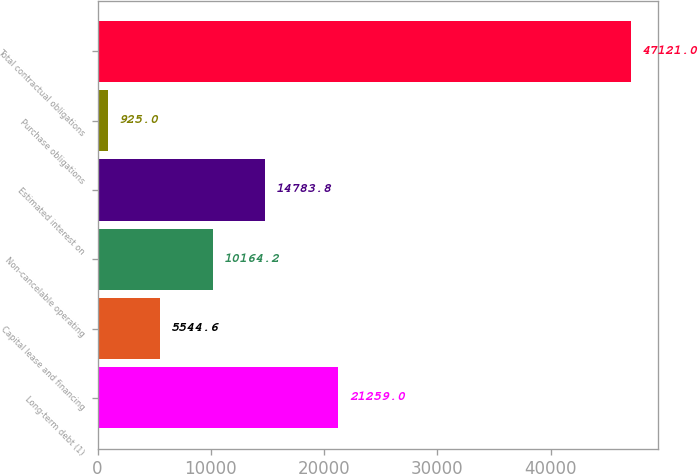<chart> <loc_0><loc_0><loc_500><loc_500><bar_chart><fcel>Long-term debt (1)<fcel>Capital lease and financing<fcel>Non-cancelable operating<fcel>Estimated interest on<fcel>Purchase obligations<fcel>Total contractual obligations<nl><fcel>21259<fcel>5544.6<fcel>10164.2<fcel>14783.8<fcel>925<fcel>47121<nl></chart> 